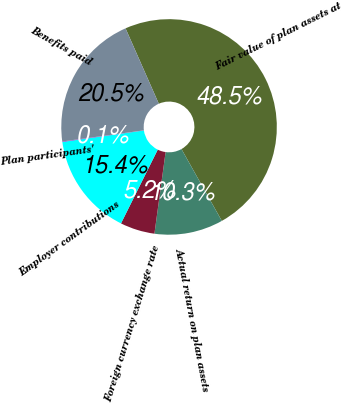Convert chart to OTSL. <chart><loc_0><loc_0><loc_500><loc_500><pie_chart><fcel>Fair value of plan assets at<fcel>Actual return on plan assets<fcel>Foreign currency exchange rate<fcel>Employer contributions<fcel>Plan participants'<fcel>Benefits paid<nl><fcel>48.47%<fcel>10.31%<fcel>5.19%<fcel>15.42%<fcel>0.07%<fcel>20.54%<nl></chart> 